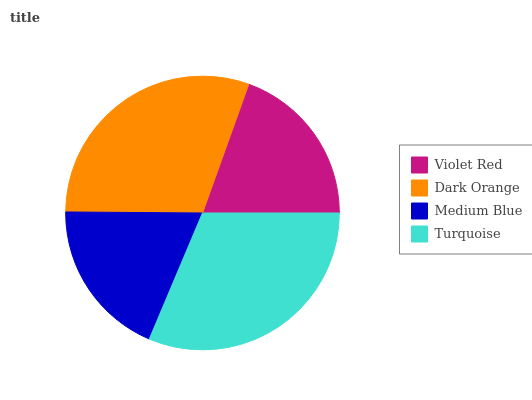Is Medium Blue the minimum?
Answer yes or no. Yes. Is Turquoise the maximum?
Answer yes or no. Yes. Is Dark Orange the minimum?
Answer yes or no. No. Is Dark Orange the maximum?
Answer yes or no. No. Is Dark Orange greater than Violet Red?
Answer yes or no. Yes. Is Violet Red less than Dark Orange?
Answer yes or no. Yes. Is Violet Red greater than Dark Orange?
Answer yes or no. No. Is Dark Orange less than Violet Red?
Answer yes or no. No. Is Dark Orange the high median?
Answer yes or no. Yes. Is Violet Red the low median?
Answer yes or no. Yes. Is Violet Red the high median?
Answer yes or no. No. Is Dark Orange the low median?
Answer yes or no. No. 